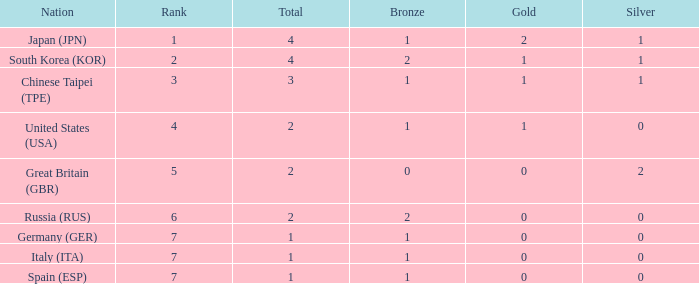How many total medals does a country with more than 1 silver medals have? 2.0. Write the full table. {'header': ['Nation', 'Rank', 'Total', 'Bronze', 'Gold', 'Silver'], 'rows': [['Japan (JPN)', '1', '4', '1', '2', '1'], ['South Korea (KOR)', '2', '4', '2', '1', '1'], ['Chinese Taipei (TPE)', '3', '3', '1', '1', '1'], ['United States (USA)', '4', '2', '1', '1', '0'], ['Great Britain (GBR)', '5', '2', '0', '0', '2'], ['Russia (RUS)', '6', '2', '2', '0', '0'], ['Germany (GER)', '7', '1', '1', '0', '0'], ['Italy (ITA)', '7', '1', '1', '0', '0'], ['Spain (ESP)', '7', '1', '1', '0', '0']]} 